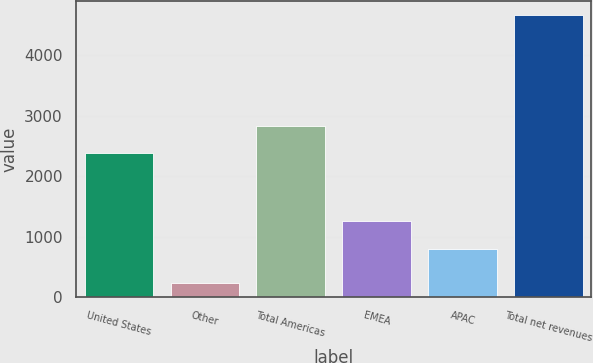<chart> <loc_0><loc_0><loc_500><loc_500><bar_chart><fcel>United States<fcel>Other<fcel>Total Americas<fcel>EMEA<fcel>APAC<fcel>Total net revenues<nl><fcel>2381.5<fcel>232<fcel>2825.21<fcel>1256.9<fcel>798.7<fcel>4669.1<nl></chart> 